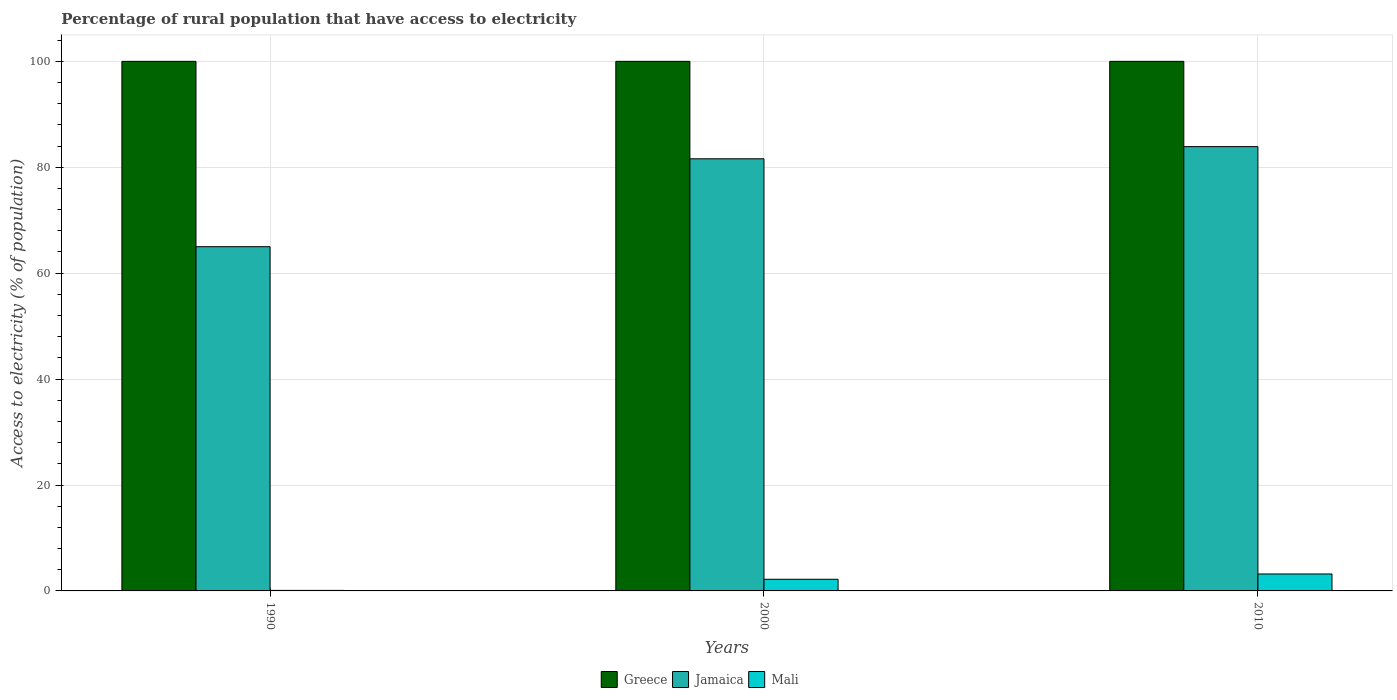How many different coloured bars are there?
Offer a terse response. 3. Are the number of bars per tick equal to the number of legend labels?
Provide a short and direct response. Yes. Are the number of bars on each tick of the X-axis equal?
Give a very brief answer. Yes. How many bars are there on the 2nd tick from the right?
Your response must be concise. 3. What is the label of the 2nd group of bars from the left?
Offer a terse response. 2000. In how many cases, is the number of bars for a given year not equal to the number of legend labels?
Make the answer very short. 0. What is the percentage of rural population that have access to electricity in Mali in 2010?
Offer a terse response. 3.2. Across all years, what is the maximum percentage of rural population that have access to electricity in Greece?
Keep it short and to the point. 100. Across all years, what is the minimum percentage of rural population that have access to electricity in Jamaica?
Offer a terse response. 65. What is the total percentage of rural population that have access to electricity in Greece in the graph?
Ensure brevity in your answer.  300. What is the difference between the percentage of rural population that have access to electricity in Mali in 2000 and that in 2010?
Provide a short and direct response. -1. What is the difference between the percentage of rural population that have access to electricity in Mali in 2010 and the percentage of rural population that have access to electricity in Greece in 1990?
Your response must be concise. -96.8. What is the average percentage of rural population that have access to electricity in Jamaica per year?
Keep it short and to the point. 76.83. In the year 2000, what is the difference between the percentage of rural population that have access to electricity in Greece and percentage of rural population that have access to electricity in Mali?
Make the answer very short. 97.8. What is the ratio of the percentage of rural population that have access to electricity in Jamaica in 1990 to that in 2010?
Your response must be concise. 0.77. Is the percentage of rural population that have access to electricity in Greece in 1990 less than that in 2000?
Provide a short and direct response. No. Is the difference between the percentage of rural population that have access to electricity in Greece in 1990 and 2000 greater than the difference between the percentage of rural population that have access to electricity in Mali in 1990 and 2000?
Your answer should be compact. Yes. What is the difference between the highest and the lowest percentage of rural population that have access to electricity in Mali?
Your response must be concise. 3.1. What does the 3rd bar from the left in 1990 represents?
Give a very brief answer. Mali. What does the 1st bar from the right in 1990 represents?
Your answer should be very brief. Mali. How many bars are there?
Your answer should be very brief. 9. Are all the bars in the graph horizontal?
Provide a succinct answer. No. How many years are there in the graph?
Give a very brief answer. 3. What is the difference between two consecutive major ticks on the Y-axis?
Your response must be concise. 20. Are the values on the major ticks of Y-axis written in scientific E-notation?
Keep it short and to the point. No. Where does the legend appear in the graph?
Provide a short and direct response. Bottom center. How many legend labels are there?
Your response must be concise. 3. What is the title of the graph?
Your answer should be compact. Percentage of rural population that have access to electricity. Does "Faeroe Islands" appear as one of the legend labels in the graph?
Provide a short and direct response. No. What is the label or title of the X-axis?
Offer a terse response. Years. What is the label or title of the Y-axis?
Provide a succinct answer. Access to electricity (% of population). What is the Access to electricity (% of population) of Greece in 1990?
Offer a terse response. 100. What is the Access to electricity (% of population) in Mali in 1990?
Your answer should be very brief. 0.1. What is the Access to electricity (% of population) in Greece in 2000?
Your answer should be very brief. 100. What is the Access to electricity (% of population) of Jamaica in 2000?
Provide a succinct answer. 81.6. What is the Access to electricity (% of population) in Mali in 2000?
Give a very brief answer. 2.2. What is the Access to electricity (% of population) of Jamaica in 2010?
Give a very brief answer. 83.9. Across all years, what is the maximum Access to electricity (% of population) of Jamaica?
Offer a very short reply. 83.9. Across all years, what is the maximum Access to electricity (% of population) in Mali?
Provide a short and direct response. 3.2. Across all years, what is the minimum Access to electricity (% of population) in Mali?
Give a very brief answer. 0.1. What is the total Access to electricity (% of population) of Greece in the graph?
Keep it short and to the point. 300. What is the total Access to electricity (% of population) of Jamaica in the graph?
Your answer should be very brief. 230.5. What is the total Access to electricity (% of population) of Mali in the graph?
Keep it short and to the point. 5.5. What is the difference between the Access to electricity (% of population) of Jamaica in 1990 and that in 2000?
Provide a succinct answer. -16.6. What is the difference between the Access to electricity (% of population) of Jamaica in 1990 and that in 2010?
Give a very brief answer. -18.9. What is the difference between the Access to electricity (% of population) in Mali in 1990 and that in 2010?
Keep it short and to the point. -3.1. What is the difference between the Access to electricity (% of population) of Greece in 2000 and that in 2010?
Provide a short and direct response. 0. What is the difference between the Access to electricity (% of population) in Jamaica in 2000 and that in 2010?
Offer a terse response. -2.3. What is the difference between the Access to electricity (% of population) in Mali in 2000 and that in 2010?
Provide a short and direct response. -1. What is the difference between the Access to electricity (% of population) of Greece in 1990 and the Access to electricity (% of population) of Mali in 2000?
Your answer should be very brief. 97.8. What is the difference between the Access to electricity (% of population) in Jamaica in 1990 and the Access to electricity (% of population) in Mali in 2000?
Your response must be concise. 62.8. What is the difference between the Access to electricity (% of population) of Greece in 1990 and the Access to electricity (% of population) of Jamaica in 2010?
Make the answer very short. 16.1. What is the difference between the Access to electricity (% of population) of Greece in 1990 and the Access to electricity (% of population) of Mali in 2010?
Keep it short and to the point. 96.8. What is the difference between the Access to electricity (% of population) of Jamaica in 1990 and the Access to electricity (% of population) of Mali in 2010?
Ensure brevity in your answer.  61.8. What is the difference between the Access to electricity (% of population) of Greece in 2000 and the Access to electricity (% of population) of Mali in 2010?
Make the answer very short. 96.8. What is the difference between the Access to electricity (% of population) of Jamaica in 2000 and the Access to electricity (% of population) of Mali in 2010?
Your response must be concise. 78.4. What is the average Access to electricity (% of population) in Jamaica per year?
Give a very brief answer. 76.83. What is the average Access to electricity (% of population) in Mali per year?
Make the answer very short. 1.83. In the year 1990, what is the difference between the Access to electricity (% of population) of Greece and Access to electricity (% of population) of Jamaica?
Ensure brevity in your answer.  35. In the year 1990, what is the difference between the Access to electricity (% of population) in Greece and Access to electricity (% of population) in Mali?
Provide a short and direct response. 99.9. In the year 1990, what is the difference between the Access to electricity (% of population) of Jamaica and Access to electricity (% of population) of Mali?
Keep it short and to the point. 64.9. In the year 2000, what is the difference between the Access to electricity (% of population) in Greece and Access to electricity (% of population) in Mali?
Your response must be concise. 97.8. In the year 2000, what is the difference between the Access to electricity (% of population) in Jamaica and Access to electricity (% of population) in Mali?
Give a very brief answer. 79.4. In the year 2010, what is the difference between the Access to electricity (% of population) of Greece and Access to electricity (% of population) of Jamaica?
Offer a very short reply. 16.1. In the year 2010, what is the difference between the Access to electricity (% of population) in Greece and Access to electricity (% of population) in Mali?
Give a very brief answer. 96.8. In the year 2010, what is the difference between the Access to electricity (% of population) of Jamaica and Access to electricity (% of population) of Mali?
Keep it short and to the point. 80.7. What is the ratio of the Access to electricity (% of population) in Greece in 1990 to that in 2000?
Offer a terse response. 1. What is the ratio of the Access to electricity (% of population) of Jamaica in 1990 to that in 2000?
Offer a terse response. 0.8. What is the ratio of the Access to electricity (% of population) in Mali in 1990 to that in 2000?
Make the answer very short. 0.05. What is the ratio of the Access to electricity (% of population) in Greece in 1990 to that in 2010?
Provide a succinct answer. 1. What is the ratio of the Access to electricity (% of population) in Jamaica in 1990 to that in 2010?
Give a very brief answer. 0.77. What is the ratio of the Access to electricity (% of population) in Mali in 1990 to that in 2010?
Your response must be concise. 0.03. What is the ratio of the Access to electricity (% of population) of Jamaica in 2000 to that in 2010?
Make the answer very short. 0.97. What is the ratio of the Access to electricity (% of population) of Mali in 2000 to that in 2010?
Ensure brevity in your answer.  0.69. What is the difference between the highest and the second highest Access to electricity (% of population) in Greece?
Provide a short and direct response. 0. What is the difference between the highest and the second highest Access to electricity (% of population) of Mali?
Your response must be concise. 1. What is the difference between the highest and the lowest Access to electricity (% of population) in Jamaica?
Provide a succinct answer. 18.9. 